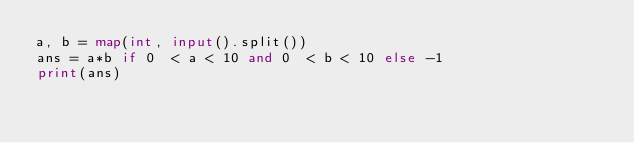<code> <loc_0><loc_0><loc_500><loc_500><_Python_>a, b = map(int, input().split())
ans = a*b if 0  < a < 10 and 0  < b < 10 else -1
print(ans)</code> 